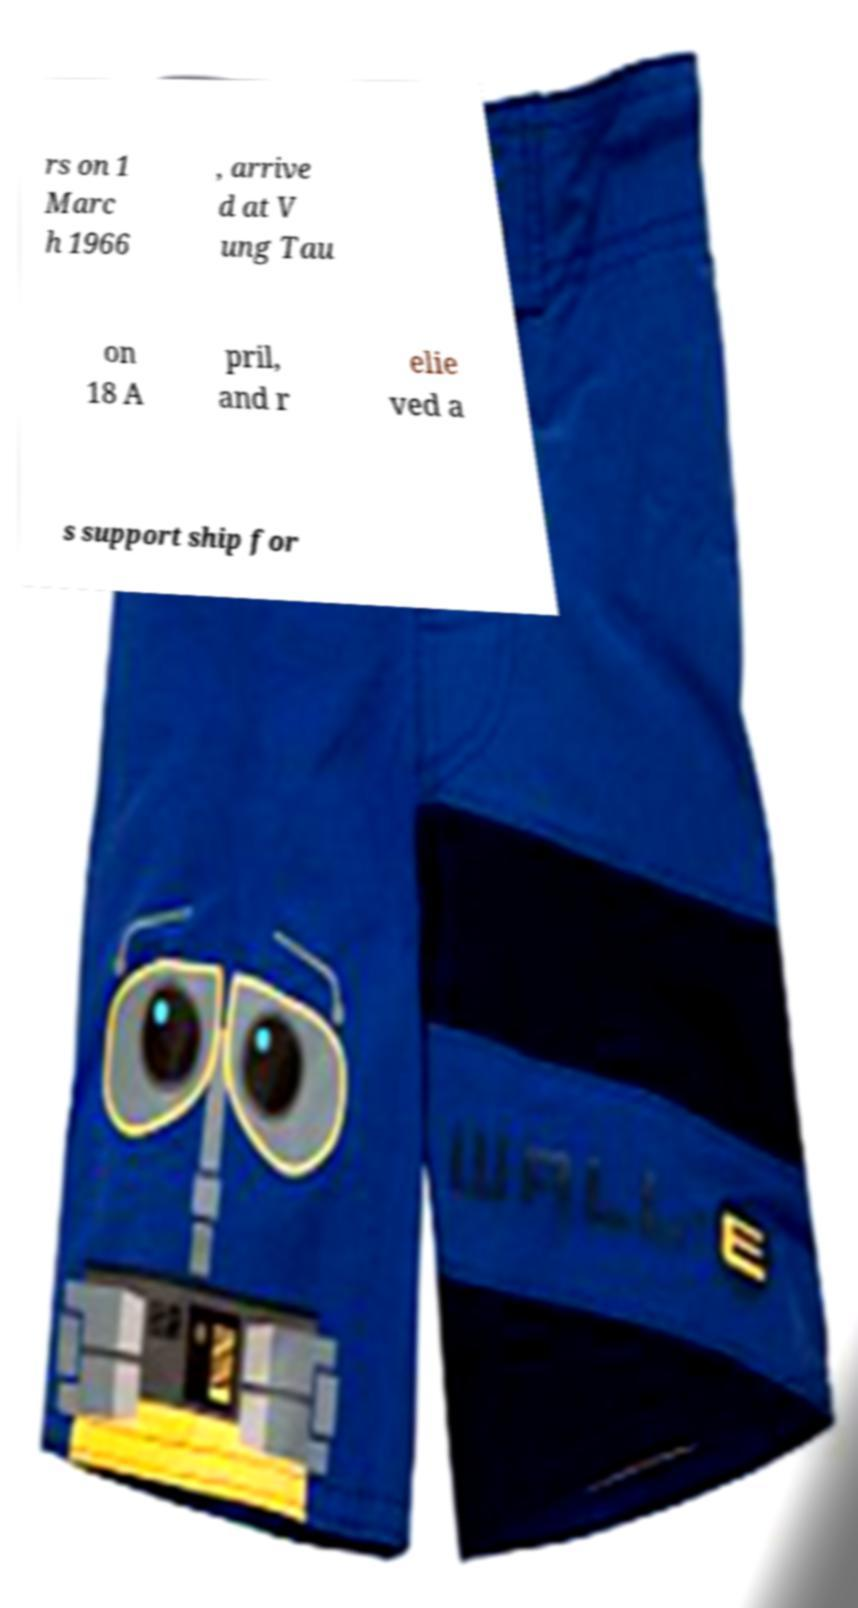Can you read and provide the text displayed in the image?This photo seems to have some interesting text. Can you extract and type it out for me? rs on 1 Marc h 1966 , arrive d at V ung Tau on 18 A pril, and r elie ved a s support ship for 